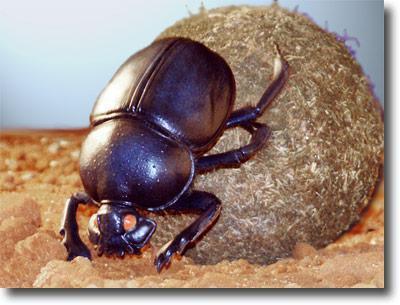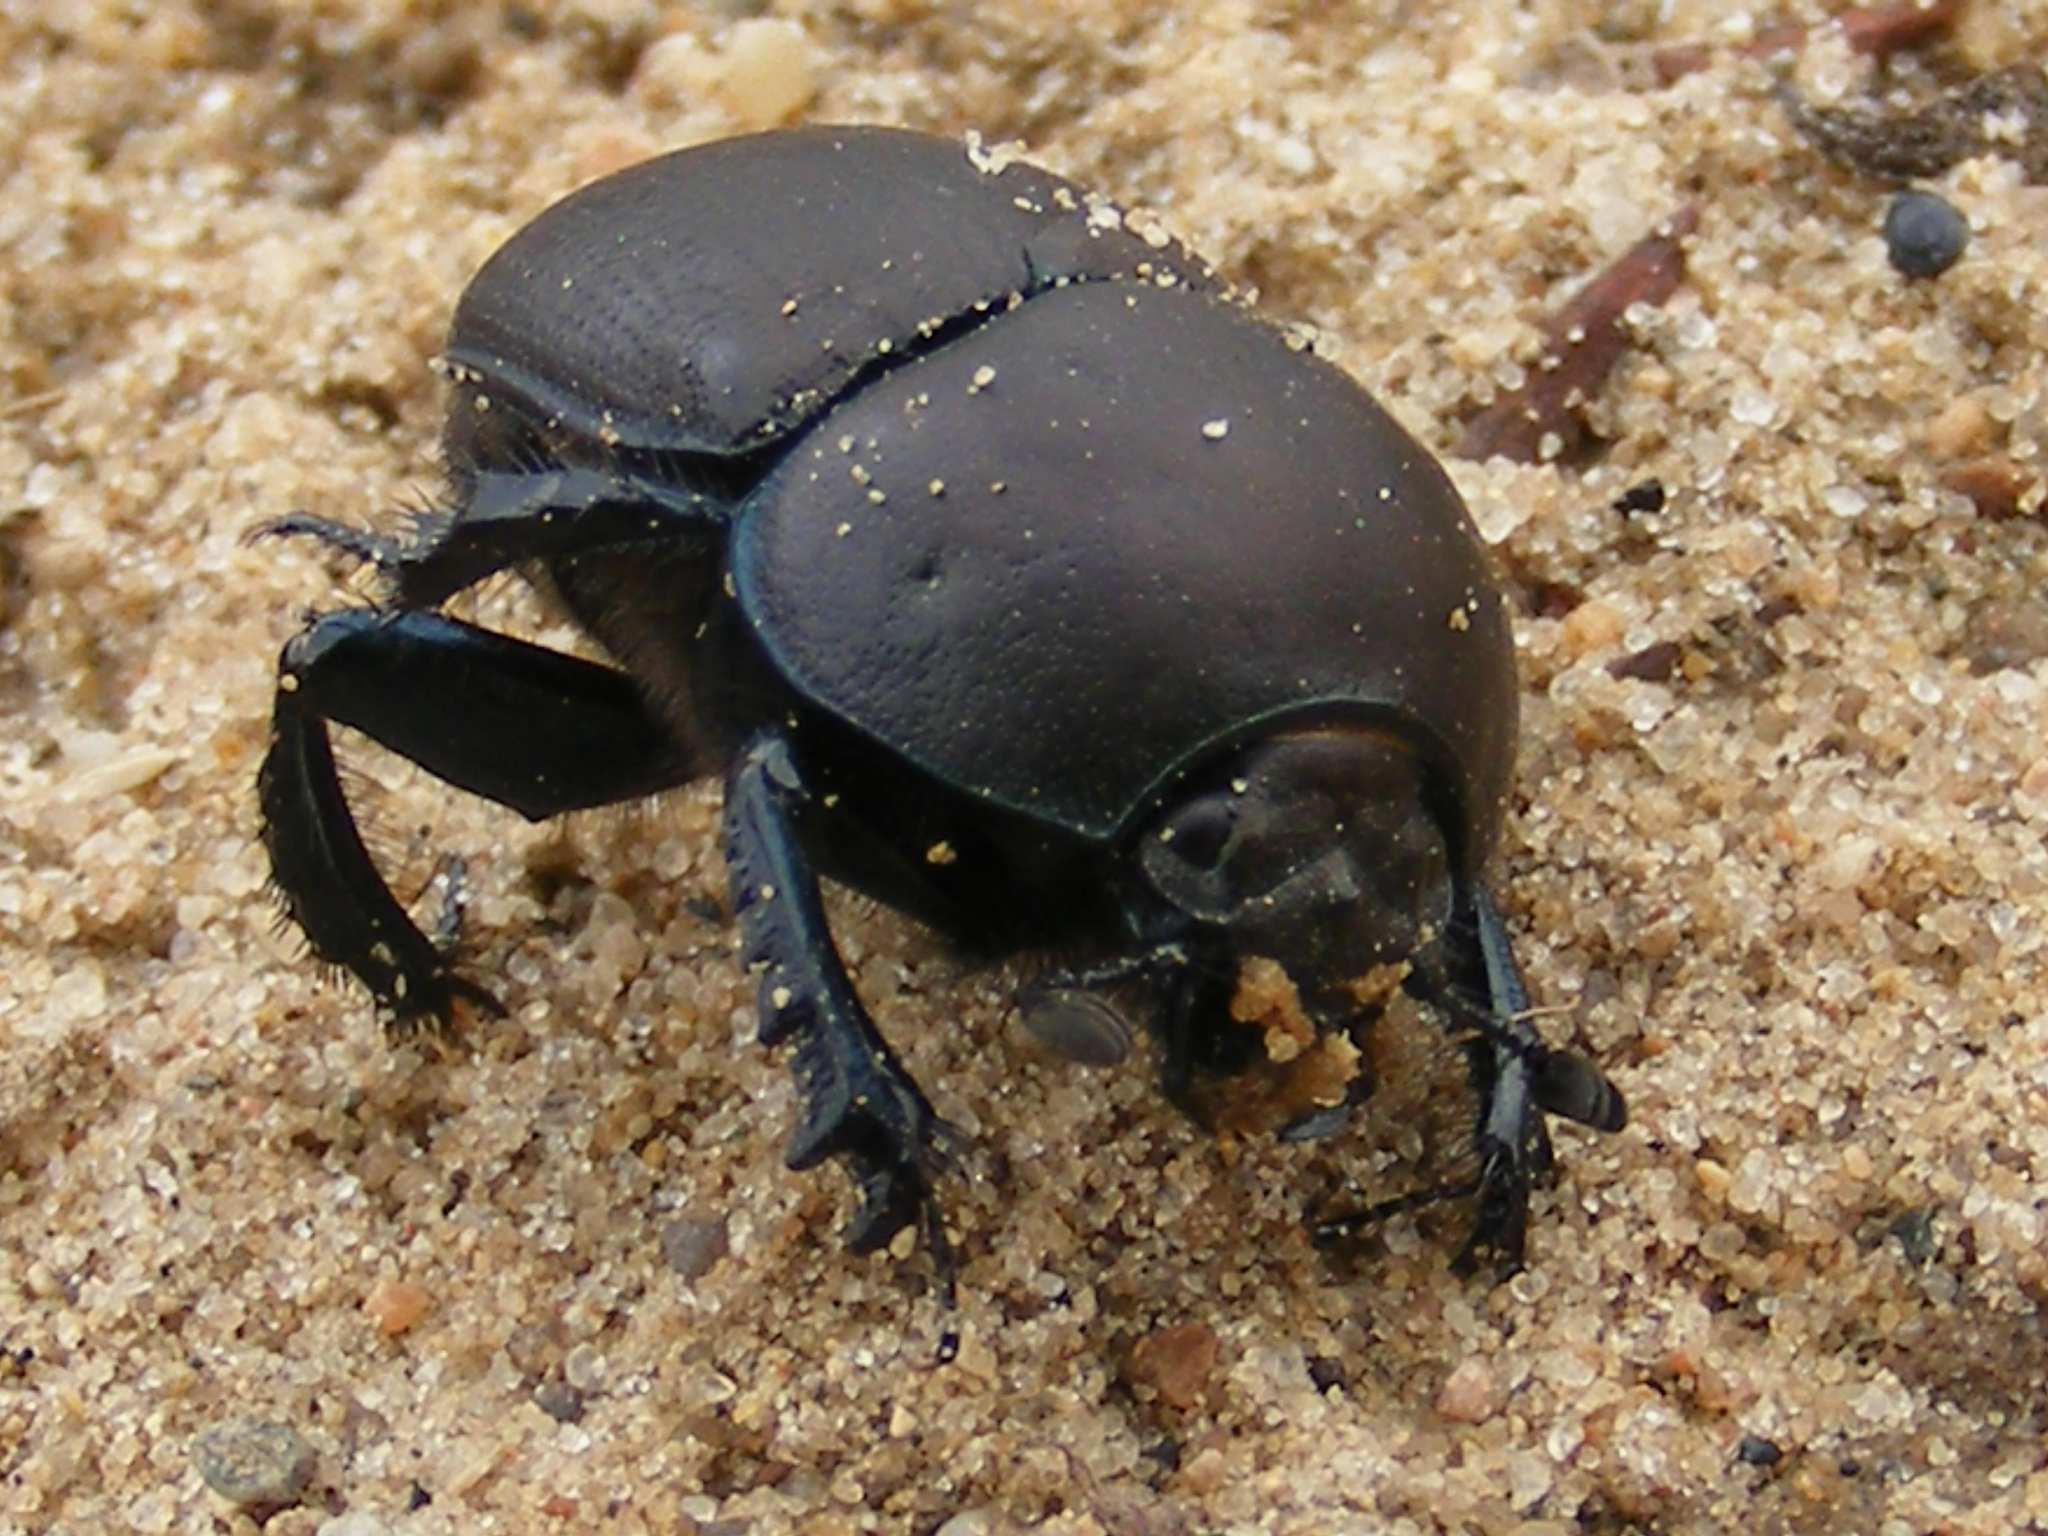The first image is the image on the left, the second image is the image on the right. Evaluate the accuracy of this statement regarding the images: "An image depicts a beetle with head facing leftward, a green iridescent hind segment, and reddish iridescence above that.". Is it true? Answer yes or no. No. The first image is the image on the left, the second image is the image on the right. Examine the images to the left and right. Is the description "All of the bugs are greenish in color." accurate? Answer yes or no. No. 